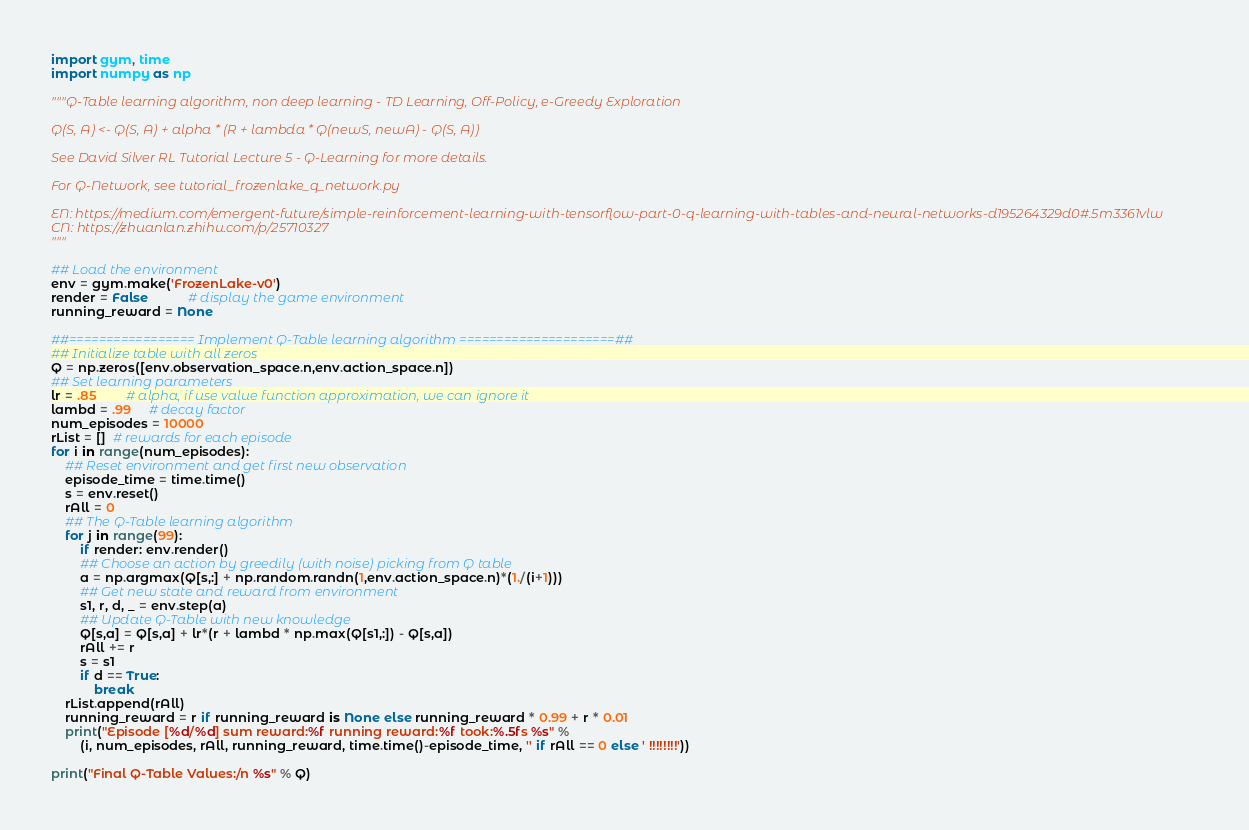<code> <loc_0><loc_0><loc_500><loc_500><_Python_>import gym, time
import numpy as np

"""Q-Table learning algorithm, non deep learning - TD Learning, Off-Policy, e-Greedy Exploration

Q(S, A) <- Q(S, A) + alpha * (R + lambda * Q(newS, newA) - Q(S, A))

See David Silver RL Tutorial Lecture 5 - Q-Learning for more details.

For Q-Network, see tutorial_frozenlake_q_network.py

EN: https://medium.com/emergent-future/simple-reinforcement-learning-with-tensorflow-part-0-q-learning-with-tables-and-neural-networks-d195264329d0#.5m3361vlw
CN: https://zhuanlan.zhihu.com/p/25710327
"""

## Load the environment
env = gym.make('FrozenLake-v0')
render = False           # display the game environment
running_reward = None

##================= Implement Q-Table learning algorithm =====================##
## Initialize table with all zeros
Q = np.zeros([env.observation_space.n,env.action_space.n])
## Set learning parameters
lr = .85        # alpha, if use value function approximation, we can ignore it
lambd = .99     # decay factor
num_episodes = 10000
rList = []  # rewards for each episode
for i in range(num_episodes):
    ## Reset environment and get first new observation
    episode_time = time.time()
    s = env.reset()
    rAll = 0
    ## The Q-Table learning algorithm
    for j in range(99):
        if render: env.render()
        ## Choose an action by greedily (with noise) picking from Q table
        a = np.argmax(Q[s,:] + np.random.randn(1,env.action_space.n)*(1./(i+1)))
        ## Get new state and reward from environment
        s1, r, d, _ = env.step(a)
        ## Update Q-Table with new knowledge
        Q[s,a] = Q[s,a] + lr*(r + lambd * np.max(Q[s1,:]) - Q[s,a])
        rAll += r
        s = s1
        if d == True:
            break
    rList.append(rAll)
    running_reward = r if running_reward is None else running_reward * 0.99 + r * 0.01
    print("Episode [%d/%d] sum reward:%f running reward:%f took:%.5fs %s" %
        (i, num_episodes, rAll, running_reward, time.time()-episode_time, '' if rAll == 0 else ' !!!!!!!!'))

print("Final Q-Table Values:/n %s" % Q)
</code> 